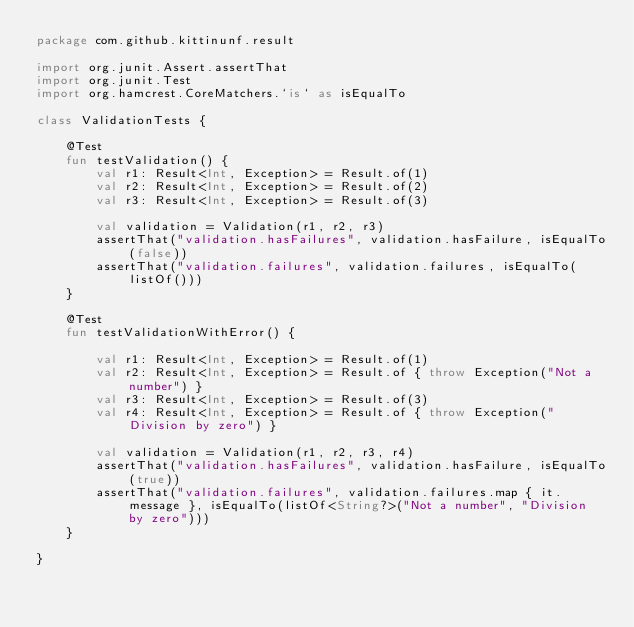Convert code to text. <code><loc_0><loc_0><loc_500><loc_500><_Kotlin_>package com.github.kittinunf.result

import org.junit.Assert.assertThat
import org.junit.Test
import org.hamcrest.CoreMatchers.`is` as isEqualTo

class ValidationTests {

    @Test
    fun testValidation() {
        val r1: Result<Int, Exception> = Result.of(1)
        val r2: Result<Int, Exception> = Result.of(2)
        val r3: Result<Int, Exception> = Result.of(3)

        val validation = Validation(r1, r2, r3)
        assertThat("validation.hasFailures", validation.hasFailure, isEqualTo(false))
        assertThat("validation.failures", validation.failures, isEqualTo(listOf()))
    }

    @Test
    fun testValidationWithError() {

        val r1: Result<Int, Exception> = Result.of(1)
        val r2: Result<Int, Exception> = Result.of { throw Exception("Not a number") }
        val r3: Result<Int, Exception> = Result.of(3)
        val r4: Result<Int, Exception> = Result.of { throw Exception("Division by zero") }

        val validation = Validation(r1, r2, r3, r4)
        assertThat("validation.hasFailures", validation.hasFailure, isEqualTo(true))
        assertThat("validation.failures", validation.failures.map { it.message }, isEqualTo(listOf<String?>("Not a number", "Division by zero")))
    }

}
</code> 